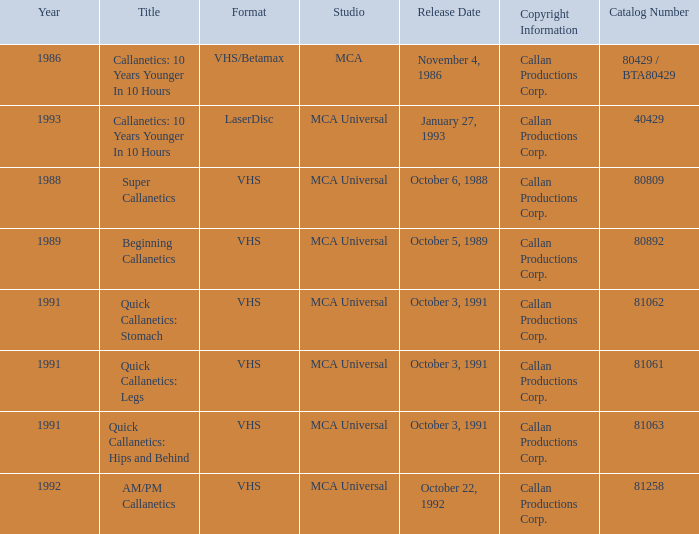Provide the catalog number associated with october 6, 1988. 80809.0. 